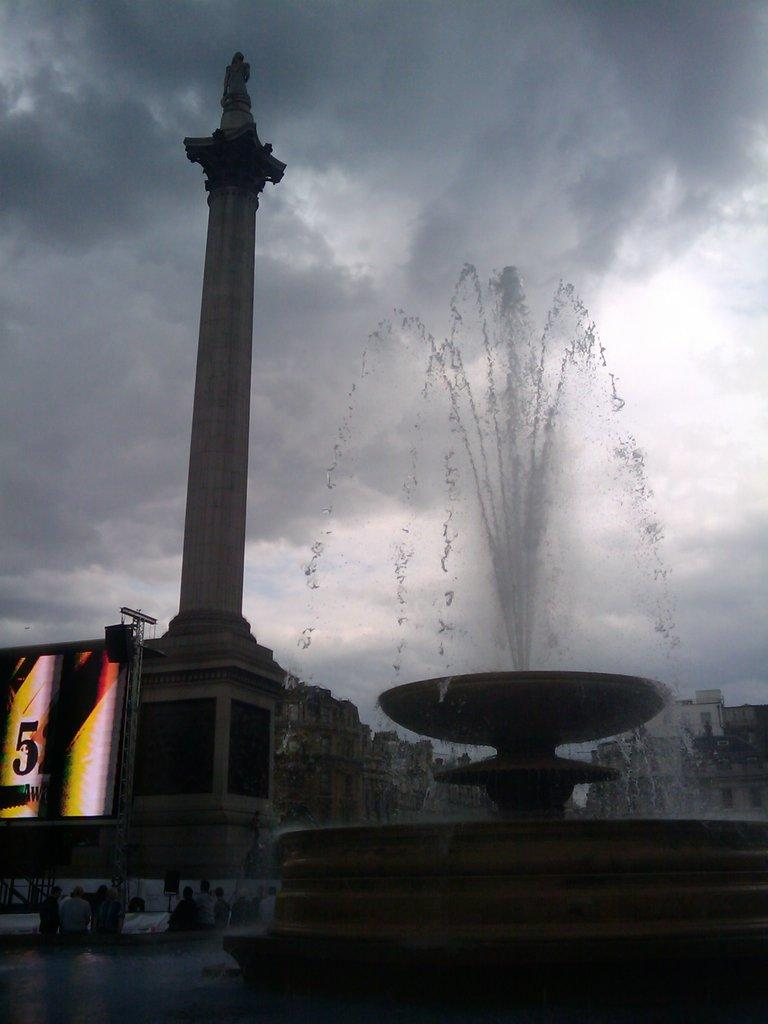<image>
Offer a succinct explanation of the picture presented. An electronic billboard with the number 5 on it is beside a water fountain in an overcast city. 